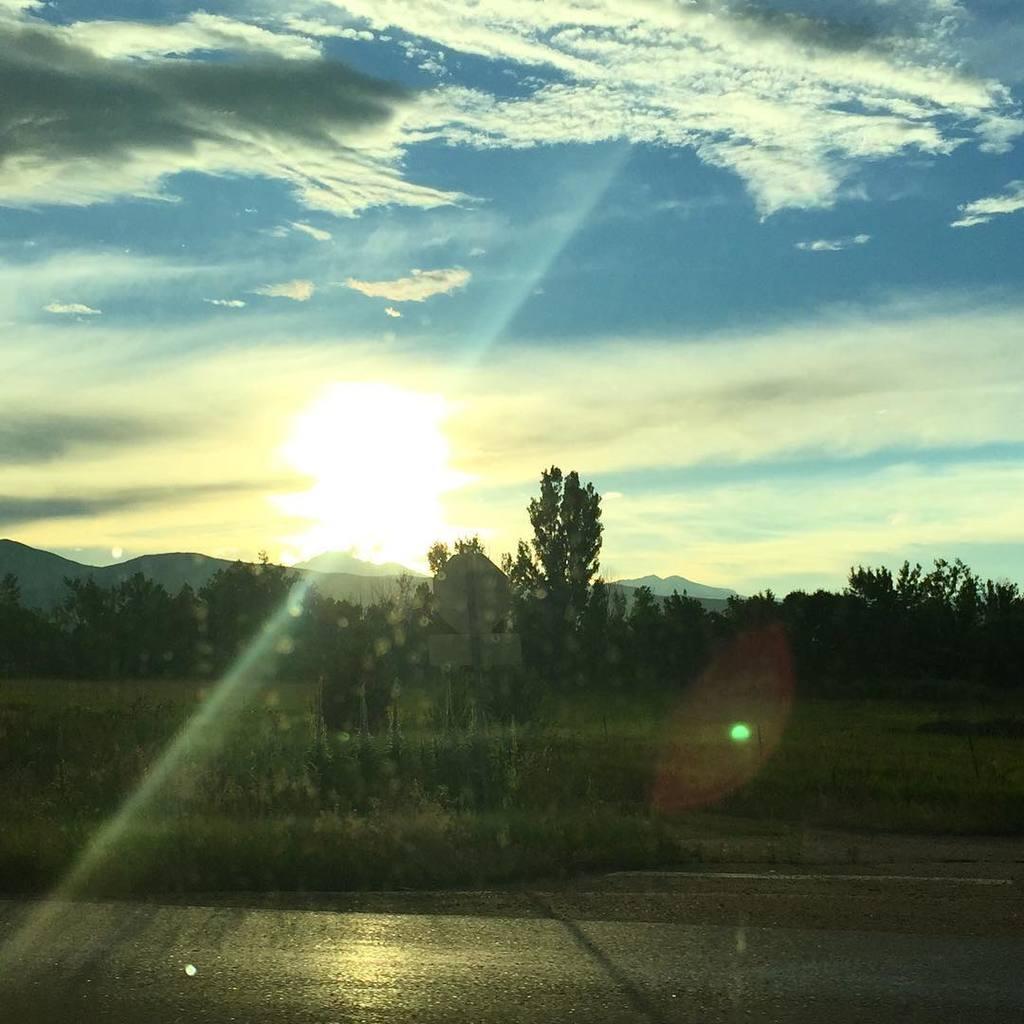How would you summarize this image in a sentence or two? At the bottom of the image there is road. In the center of the image there are trees,grass. In the background of the image there are mountains,sky and sun. 